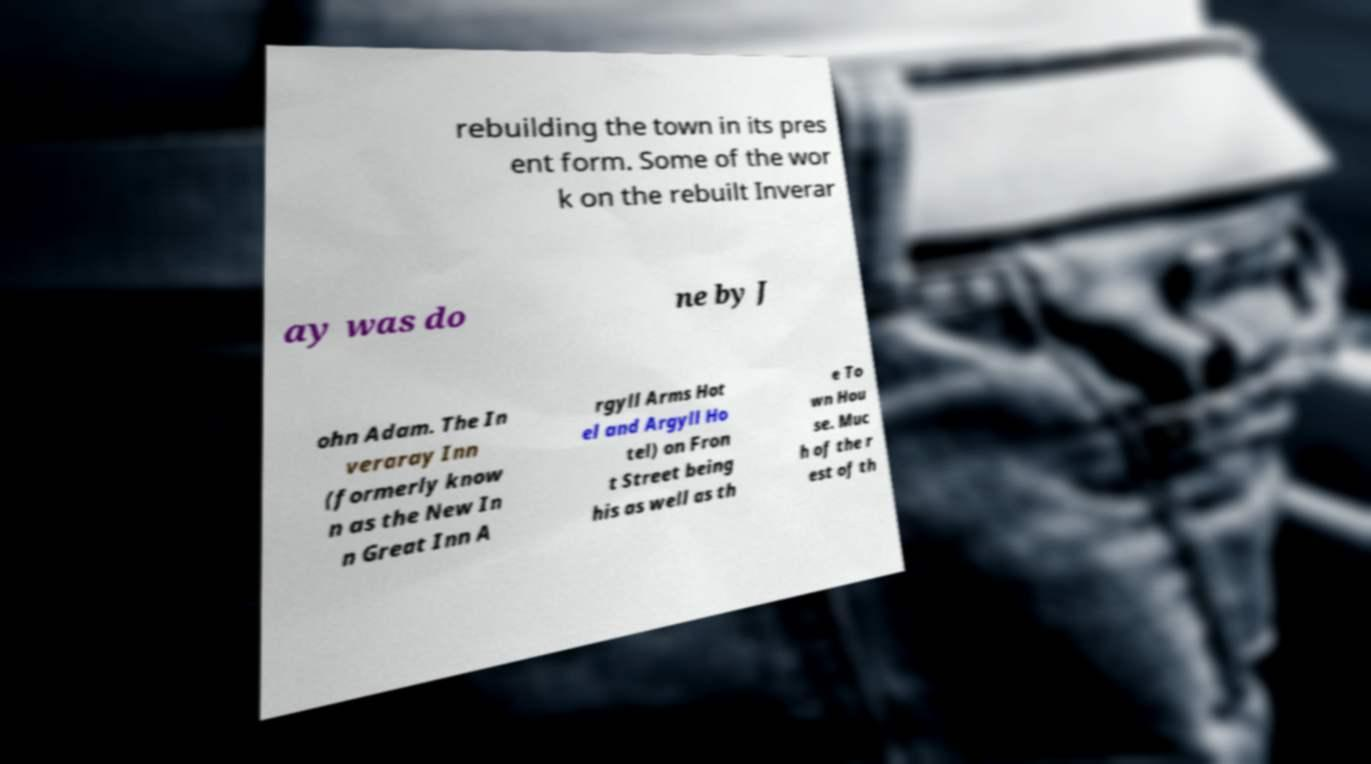What messages or text are displayed in this image? I need them in a readable, typed format. rebuilding the town in its pres ent form. Some of the wor k on the rebuilt Inverar ay was do ne by J ohn Adam. The In veraray Inn (formerly know n as the New In n Great Inn A rgyll Arms Hot el and Argyll Ho tel) on Fron t Street being his as well as th e To wn Hou se. Muc h of the r est of th 